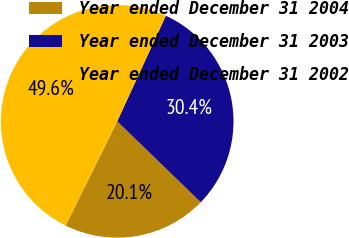Convert chart to OTSL. <chart><loc_0><loc_0><loc_500><loc_500><pie_chart><fcel>Year ended December 31 2004<fcel>Year ended December 31 2003<fcel>Year ended December 31 2002<nl><fcel>20.07%<fcel>30.37%<fcel>49.56%<nl></chart> 